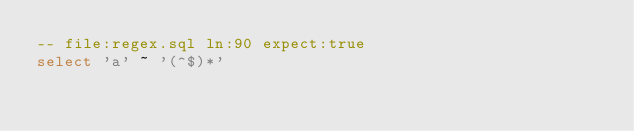<code> <loc_0><loc_0><loc_500><loc_500><_SQL_>-- file:regex.sql ln:90 expect:true
select 'a' ~ '(^$)*'
</code> 